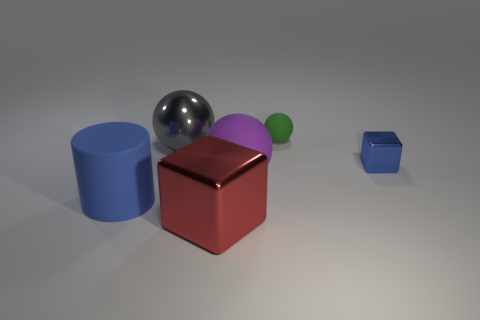There is a object on the right side of the small ball; is its size the same as the cube to the left of the tiny matte object?
Offer a very short reply. No. How many big objects are either gray shiny spheres or rubber things?
Your answer should be compact. 3. How many large things are both in front of the large purple matte thing and right of the big cylinder?
Ensure brevity in your answer.  1. Does the blue cylinder have the same material as the big thing in front of the big blue matte thing?
Provide a short and direct response. No. What number of gray things are either tiny balls or small objects?
Your response must be concise. 0. Is there a blue cylinder that has the same size as the blue shiny object?
Offer a very short reply. No. There is a big ball that is in front of the large metallic thing behind the metallic block that is behind the purple object; what is it made of?
Give a very brief answer. Rubber. Are there an equal number of blue shiny things that are behind the green rubber thing and spheres?
Your answer should be very brief. No. Is the blue thing that is behind the big purple sphere made of the same material as the big object that is to the right of the red metal cube?
Offer a terse response. No. How many objects are blue rubber blocks or big objects on the right side of the cylinder?
Keep it short and to the point. 3. 